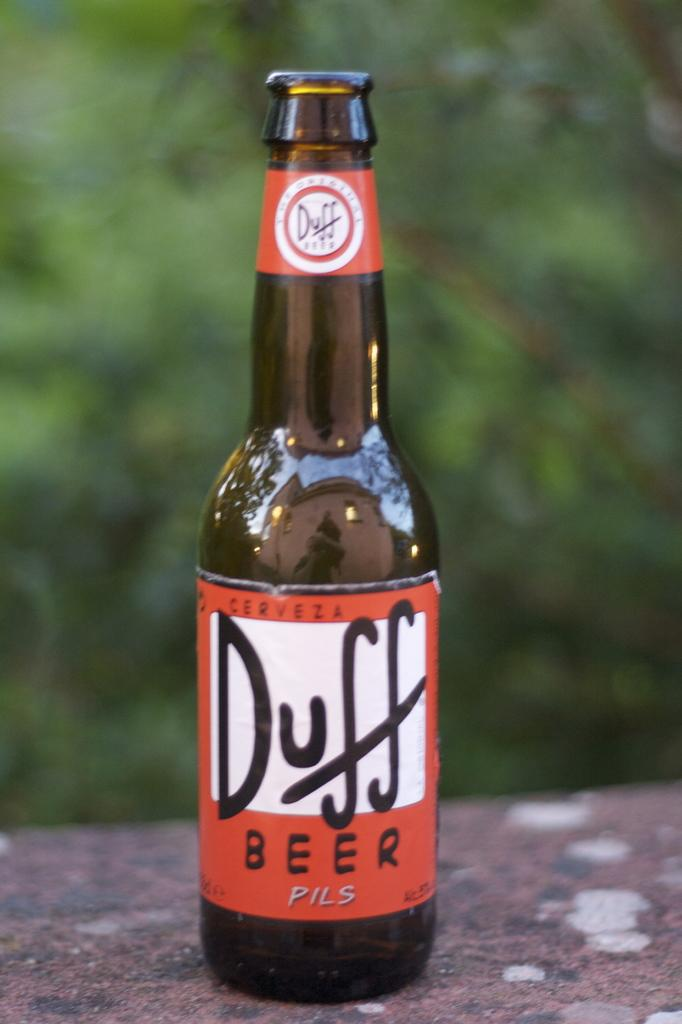<image>
Offer a succinct explanation of the picture presented. A bottle of Duff beer is opened with greenery in the background. 